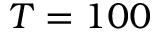<formula> <loc_0><loc_0><loc_500><loc_500>T = 1 0 0</formula> 